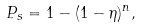Convert formula to latex. <formula><loc_0><loc_0><loc_500><loc_500>P _ { s } = 1 - ( 1 - \eta ) ^ { n } ,</formula> 